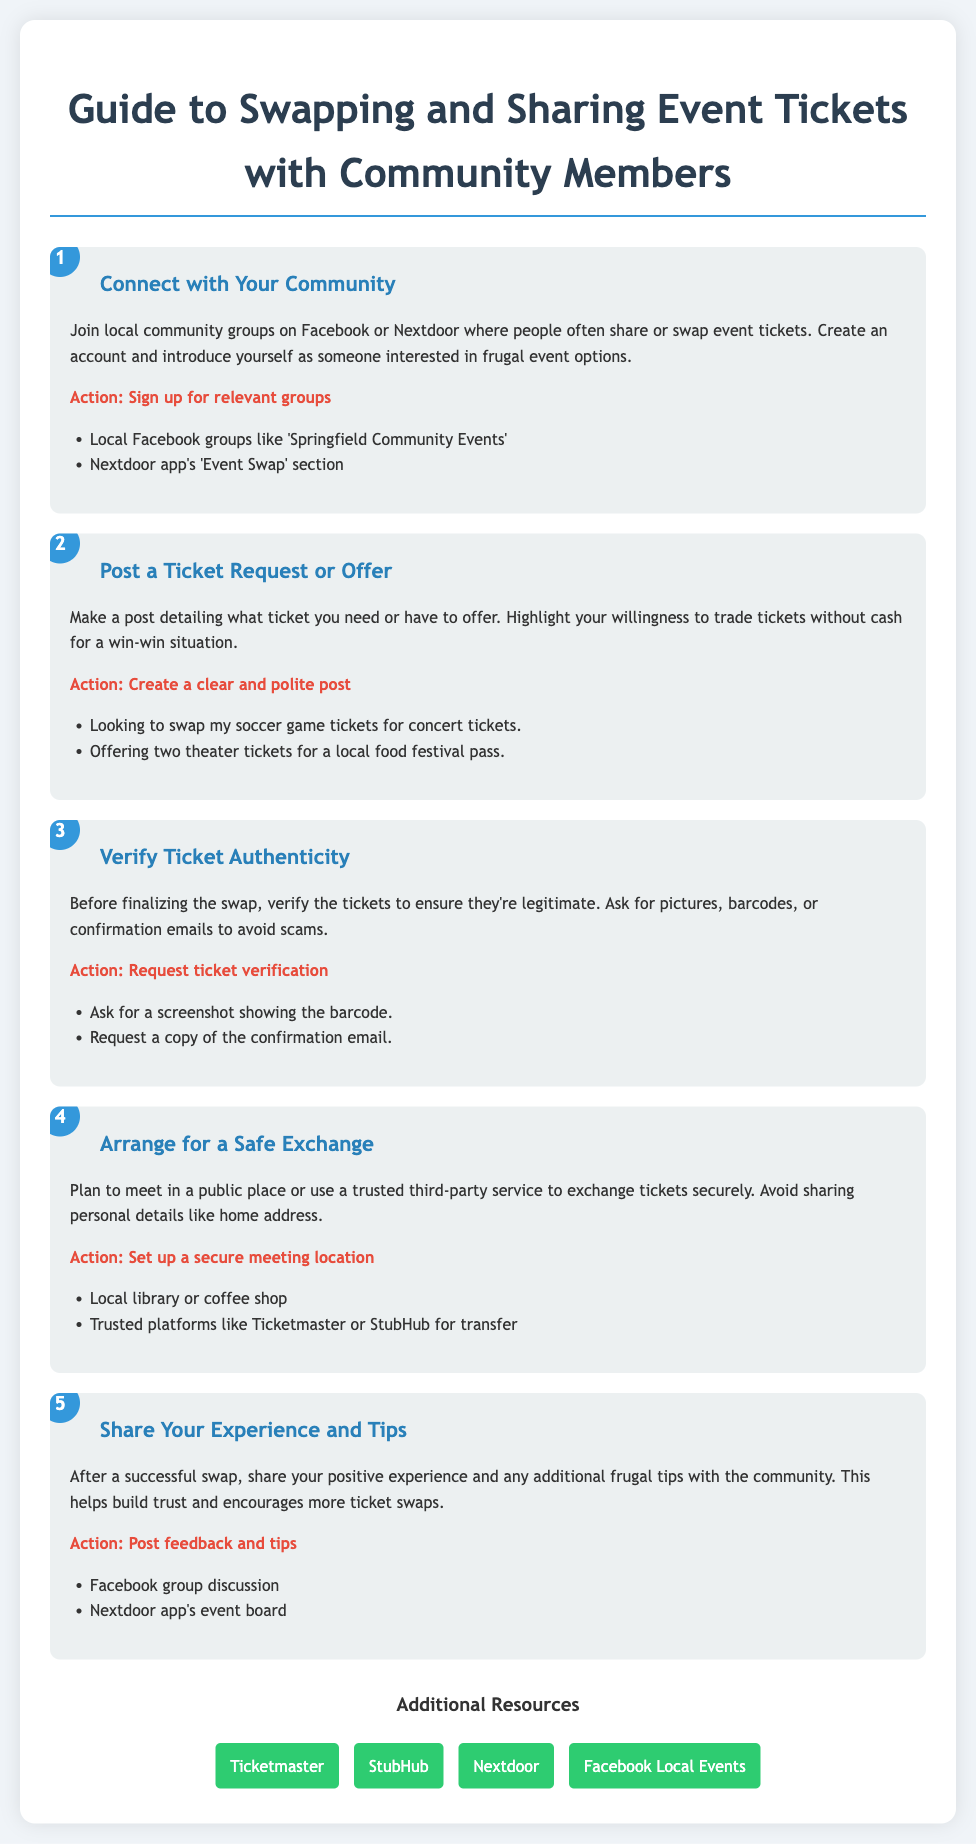what is the title of the document? The title of the document is specified in the header section.
Answer: Guide to Swapping and Sharing Event Tickets with Community Members how many steps are outlined in the process? The number of steps is indicated in the document; there are five subsequent steps listed.
Answer: 5 what is the first action suggested in the process? The first action is mentioned in the description of the initial step.
Answer: Sign up for relevant groups which social media platforms are recommended for finding community groups? The document lists specific platforms in the first step description.
Answer: Facebook and Nextdoor what should you request to verify ticket authenticity? The document details required verification items in the third step action.
Answer: Ticket verification where is a safe place suggested for exchanging tickets? The suggested locations for ticket exchanges are provided in the fourth step description.
Answer: Local library or coffee shop what can you share after a successful ticket swap? The document mentions this in the last step regarding what to do post-swap.
Answer: Feedback and tips what color is used for the step numbers? The color of the step numbers is detailed in the style section of the code.
Answer: Blue which external platform is mentioned for buying tickets? The additional resources section provides links to various platforms.
Answer: Ticketmaster 